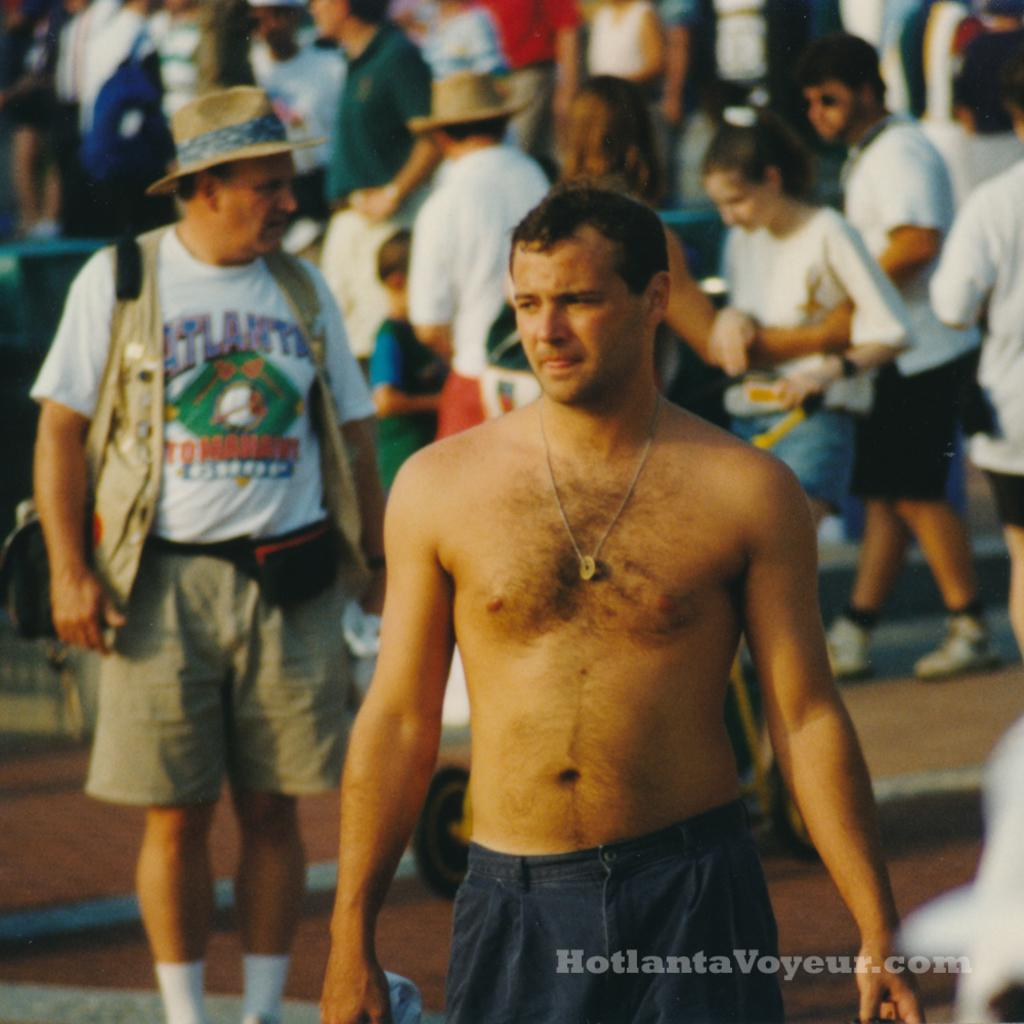<image>
Offer a succinct explanation of the picture presented. the word voyeur that is on a website name 